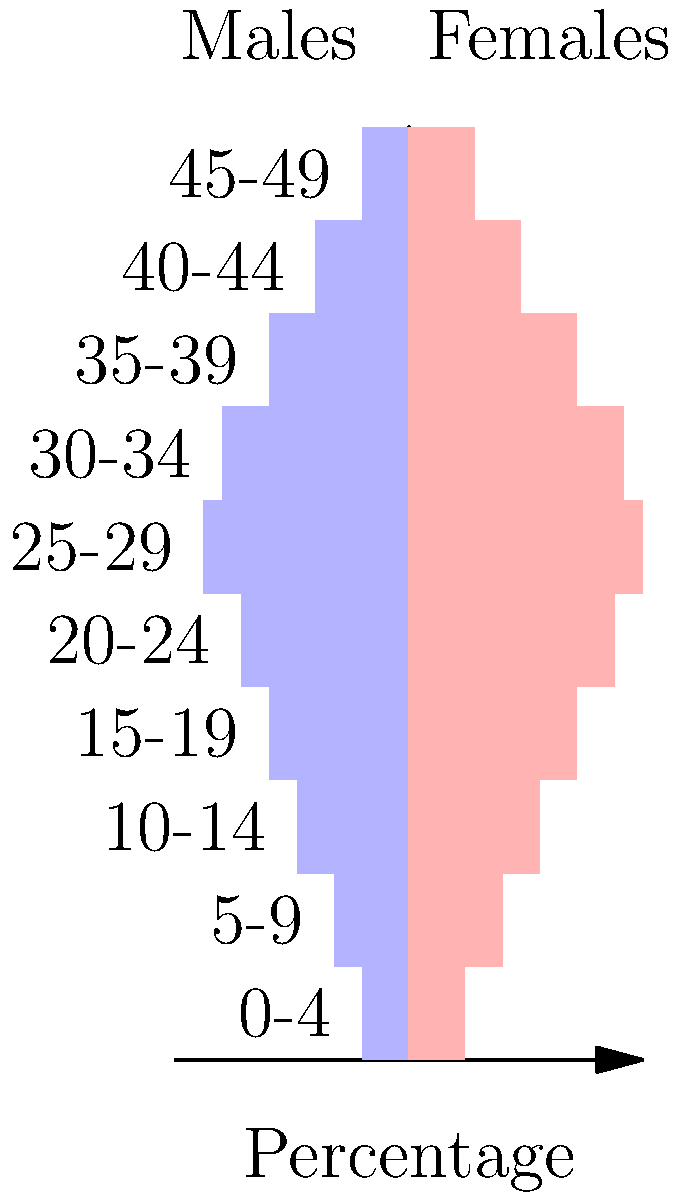Based on the population pyramid of single-parent families shown, estimate the percentage of children aged 0-9 who may require childcare services. Assume that 80% of single parents with children in this age group need childcare. To estimate the childcare demand for children aged 0-9, we need to follow these steps:

1. Identify the relevant age groups: 0-4 and 5-9.

2. Calculate the total percentage of children in these age groups:
   - Males 0-4: 5%, Females 0-4: 6%
   - Males 5-9: 8%, Females 5-9: 10%
   - Total = 5% + 6% + 8% + 10% = 29%

3. Assume 80% of these children need childcare:
   $29\% \times 0.80 = 23.2\%$

4. Round to the nearest whole percentage:
   $23.2\% \approx 23\%$

Therefore, we estimate that approximately 23% of children aged 0-9 in single-parent families may require childcare services.
Answer: 23% 